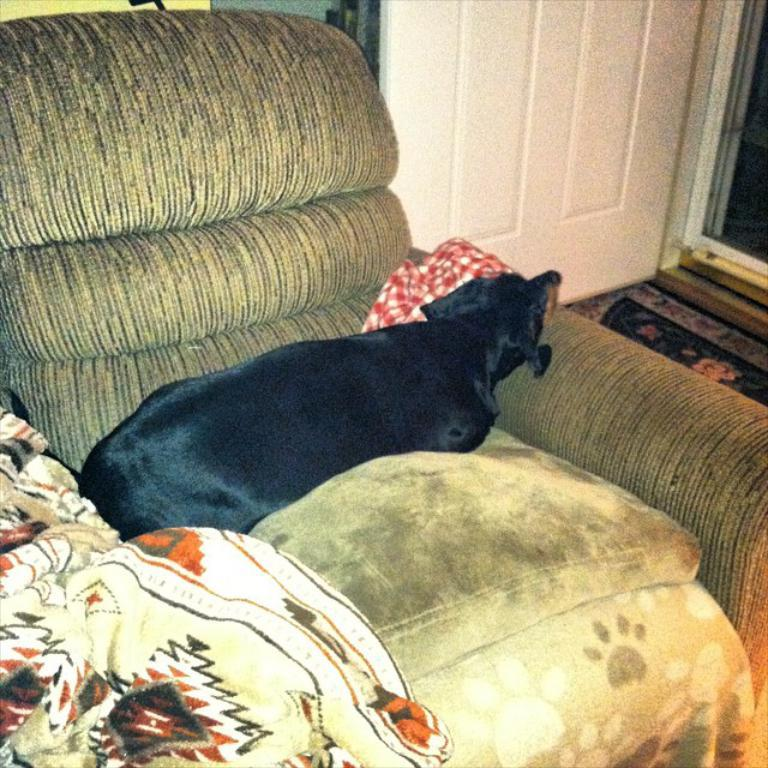What animal can be seen in the image? There is a dog in the image. What is the dog doing in the image? The dog is sitting on a chair. What architectural feature is visible in the top right of the image? There is a door visible in the top right of the image. What type of leaf is the dog holding in its mouth in the image? There is no leaf present in the image; the dog is sitting on a chair without any object in its mouth. 